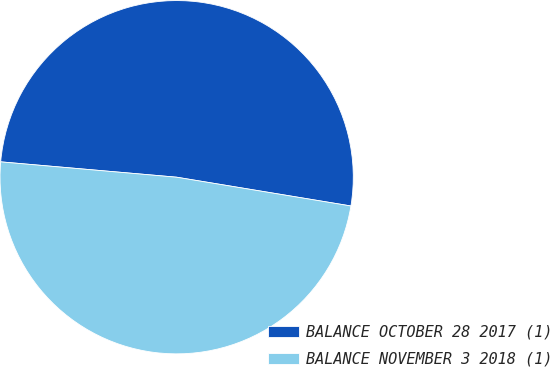Convert chart. <chart><loc_0><loc_0><loc_500><loc_500><pie_chart><fcel>BALANCE OCTOBER 28 2017 (1)<fcel>BALANCE NOVEMBER 3 2018 (1)<nl><fcel>51.22%<fcel>48.78%<nl></chart> 